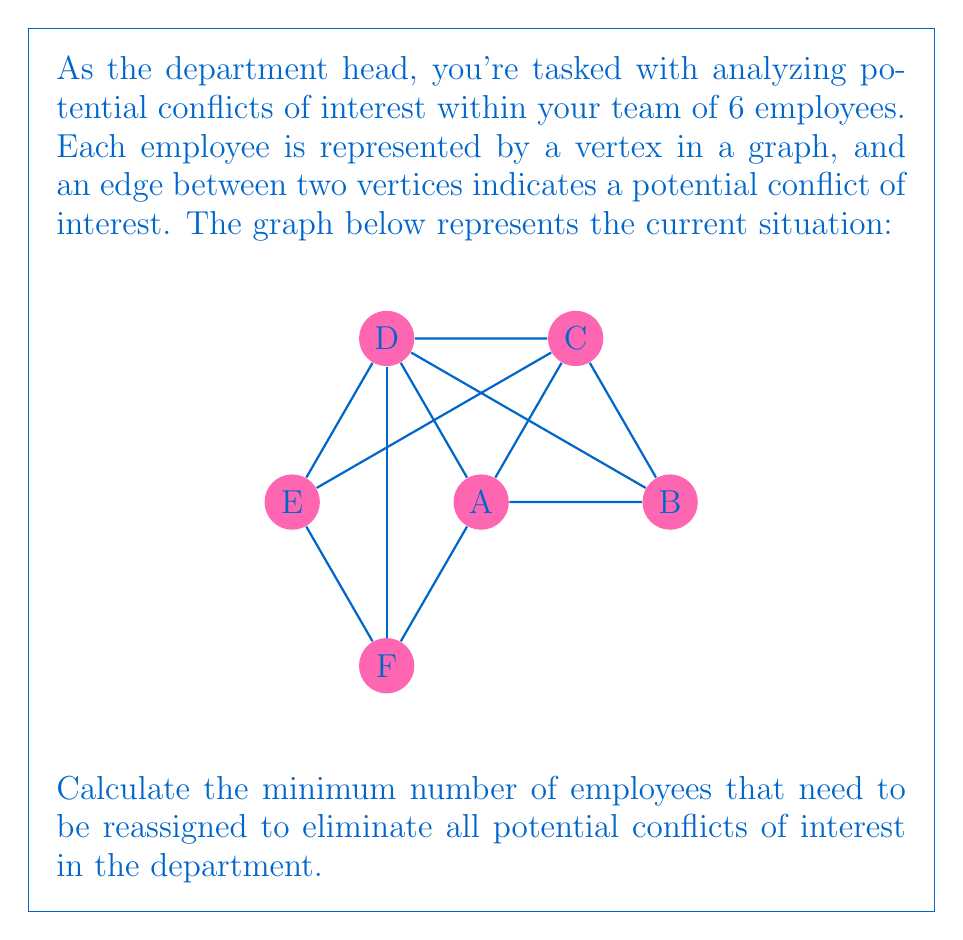Give your solution to this math problem. To solve this problem, we need to find the maximum independent set in the graph. An independent set is a set of vertices in a graph, no two of which are adjacent. The maximum independent set represents the largest group of employees that can work together without any conflicts of interest.

Step 1: Identify all possible independent sets in the graph.
- {A}, {B}, {C}, {D}, {E}, {F}
- {A,E}, {B,E}, {C,F}, {D,F}
- {B,D,F}

Step 2: Determine the maximum independent set.
The largest independent set is {B,D,F} with 3 vertices.

Step 3: Calculate the number of employees to be reassigned.
Total employees = 6
Employees in the maximum independent set = 3
Employees to be reassigned = 6 - 3 = 3

Therefore, the minimum number of employees that need to be reassigned to eliminate all potential conflicts of interest is 3.

This solution ensures that we maintain the largest possible group of employees without conflicts while minimizing the number of reassignments, thus upholding ethical standards and impartiality in the department.
Answer: 3 employees 